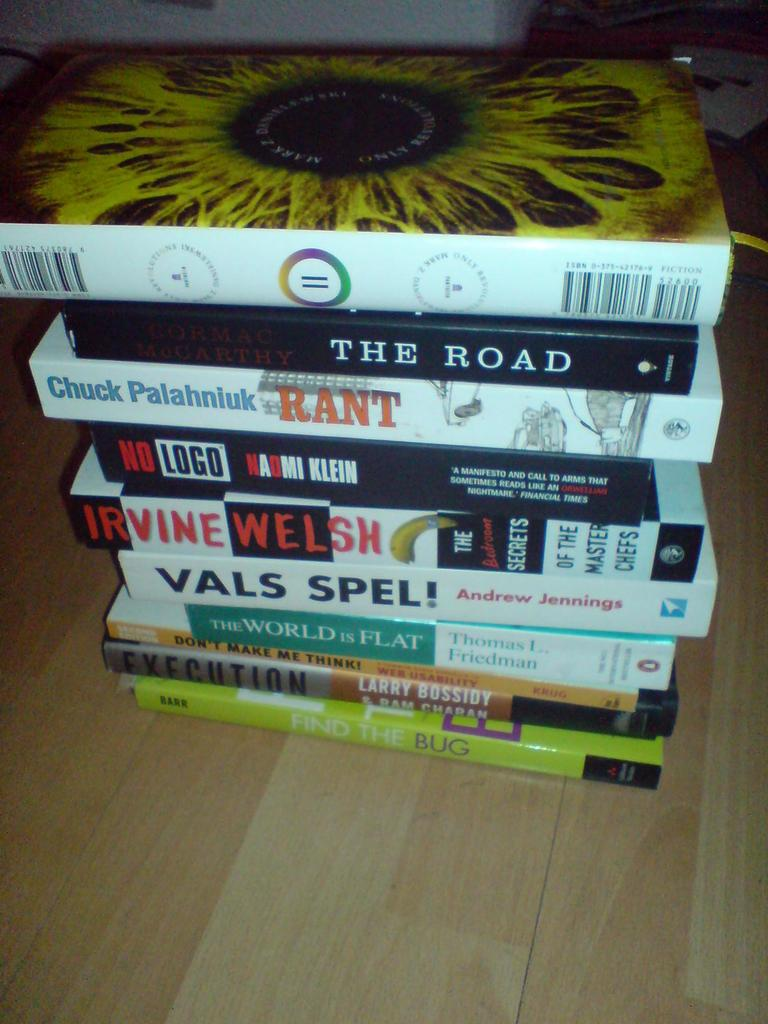<image>
Describe the image concisely. A collection of books stacked on a hardwood floor, including The Road and No Logo among others. 